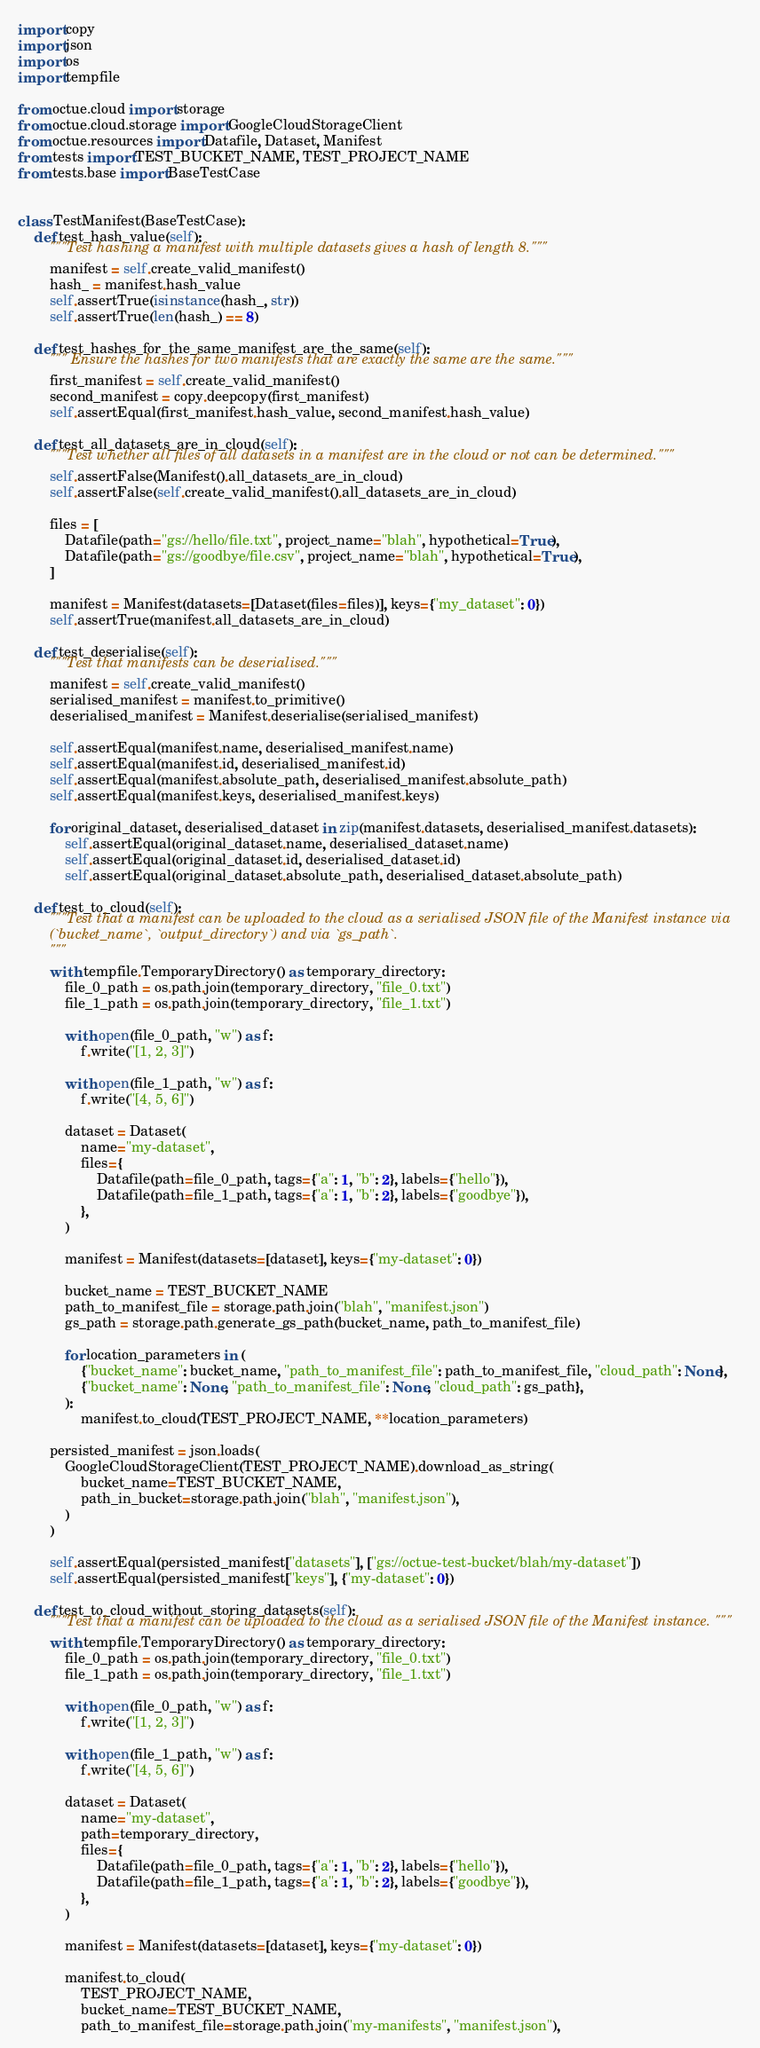<code> <loc_0><loc_0><loc_500><loc_500><_Python_>import copy
import json
import os
import tempfile

from octue.cloud import storage
from octue.cloud.storage import GoogleCloudStorageClient
from octue.resources import Datafile, Dataset, Manifest
from tests import TEST_BUCKET_NAME, TEST_PROJECT_NAME
from tests.base import BaseTestCase


class TestManifest(BaseTestCase):
    def test_hash_value(self):
        """Test hashing a manifest with multiple datasets gives a hash of length 8."""
        manifest = self.create_valid_manifest()
        hash_ = manifest.hash_value
        self.assertTrue(isinstance(hash_, str))
        self.assertTrue(len(hash_) == 8)

    def test_hashes_for_the_same_manifest_are_the_same(self):
        """ Ensure the hashes for two manifests that are exactly the same are the same."""
        first_manifest = self.create_valid_manifest()
        second_manifest = copy.deepcopy(first_manifest)
        self.assertEqual(first_manifest.hash_value, second_manifest.hash_value)

    def test_all_datasets_are_in_cloud(self):
        """Test whether all files of all datasets in a manifest are in the cloud or not can be determined."""
        self.assertFalse(Manifest().all_datasets_are_in_cloud)
        self.assertFalse(self.create_valid_manifest().all_datasets_are_in_cloud)

        files = [
            Datafile(path="gs://hello/file.txt", project_name="blah", hypothetical=True),
            Datafile(path="gs://goodbye/file.csv", project_name="blah", hypothetical=True),
        ]

        manifest = Manifest(datasets=[Dataset(files=files)], keys={"my_dataset": 0})
        self.assertTrue(manifest.all_datasets_are_in_cloud)

    def test_deserialise(self):
        """Test that manifests can be deserialised."""
        manifest = self.create_valid_manifest()
        serialised_manifest = manifest.to_primitive()
        deserialised_manifest = Manifest.deserialise(serialised_manifest)

        self.assertEqual(manifest.name, deserialised_manifest.name)
        self.assertEqual(manifest.id, deserialised_manifest.id)
        self.assertEqual(manifest.absolute_path, deserialised_manifest.absolute_path)
        self.assertEqual(manifest.keys, deserialised_manifest.keys)

        for original_dataset, deserialised_dataset in zip(manifest.datasets, deserialised_manifest.datasets):
            self.assertEqual(original_dataset.name, deserialised_dataset.name)
            self.assertEqual(original_dataset.id, deserialised_dataset.id)
            self.assertEqual(original_dataset.absolute_path, deserialised_dataset.absolute_path)

    def test_to_cloud(self):
        """Test that a manifest can be uploaded to the cloud as a serialised JSON file of the Manifest instance via
        (`bucket_name`, `output_directory`) and via `gs_path`.
        """
        with tempfile.TemporaryDirectory() as temporary_directory:
            file_0_path = os.path.join(temporary_directory, "file_0.txt")
            file_1_path = os.path.join(temporary_directory, "file_1.txt")

            with open(file_0_path, "w") as f:
                f.write("[1, 2, 3]")

            with open(file_1_path, "w") as f:
                f.write("[4, 5, 6]")

            dataset = Dataset(
                name="my-dataset",
                files={
                    Datafile(path=file_0_path, tags={"a": 1, "b": 2}, labels={"hello"}),
                    Datafile(path=file_1_path, tags={"a": 1, "b": 2}, labels={"goodbye"}),
                },
            )

            manifest = Manifest(datasets=[dataset], keys={"my-dataset": 0})

            bucket_name = TEST_BUCKET_NAME
            path_to_manifest_file = storage.path.join("blah", "manifest.json")
            gs_path = storage.path.generate_gs_path(bucket_name, path_to_manifest_file)

            for location_parameters in (
                {"bucket_name": bucket_name, "path_to_manifest_file": path_to_manifest_file, "cloud_path": None},
                {"bucket_name": None, "path_to_manifest_file": None, "cloud_path": gs_path},
            ):
                manifest.to_cloud(TEST_PROJECT_NAME, **location_parameters)

        persisted_manifest = json.loads(
            GoogleCloudStorageClient(TEST_PROJECT_NAME).download_as_string(
                bucket_name=TEST_BUCKET_NAME,
                path_in_bucket=storage.path.join("blah", "manifest.json"),
            )
        )

        self.assertEqual(persisted_manifest["datasets"], ["gs://octue-test-bucket/blah/my-dataset"])
        self.assertEqual(persisted_manifest["keys"], {"my-dataset": 0})

    def test_to_cloud_without_storing_datasets(self):
        """Test that a manifest can be uploaded to the cloud as a serialised JSON file of the Manifest instance. """
        with tempfile.TemporaryDirectory() as temporary_directory:
            file_0_path = os.path.join(temporary_directory, "file_0.txt")
            file_1_path = os.path.join(temporary_directory, "file_1.txt")

            with open(file_0_path, "w") as f:
                f.write("[1, 2, 3]")

            with open(file_1_path, "w") as f:
                f.write("[4, 5, 6]")

            dataset = Dataset(
                name="my-dataset",
                path=temporary_directory,
                files={
                    Datafile(path=file_0_path, tags={"a": 1, "b": 2}, labels={"hello"}),
                    Datafile(path=file_1_path, tags={"a": 1, "b": 2}, labels={"goodbye"}),
                },
            )

            manifest = Manifest(datasets=[dataset], keys={"my-dataset": 0})

            manifest.to_cloud(
                TEST_PROJECT_NAME,
                bucket_name=TEST_BUCKET_NAME,
                path_to_manifest_file=storage.path.join("my-manifests", "manifest.json"),</code> 